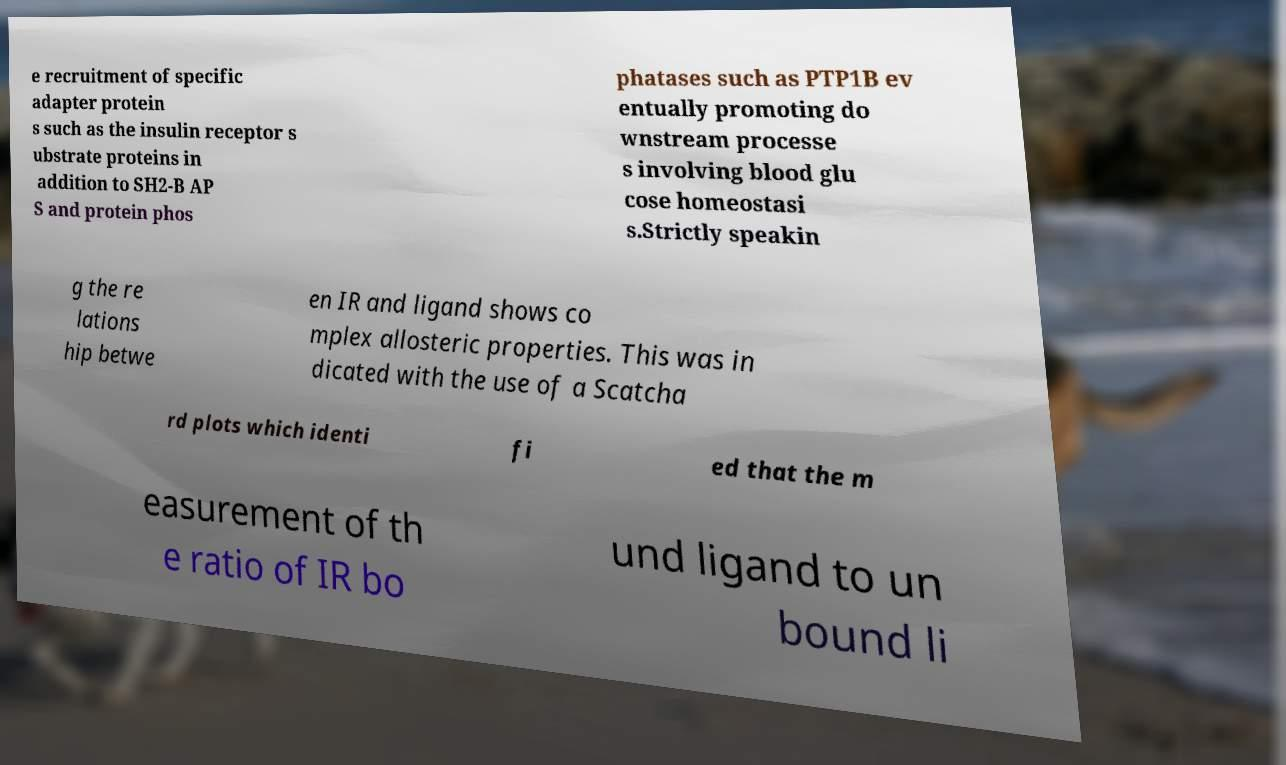There's text embedded in this image that I need extracted. Can you transcribe it verbatim? e recruitment of specific adapter protein s such as the insulin receptor s ubstrate proteins in addition to SH2-B AP S and protein phos phatases such as PTP1B ev entually promoting do wnstream processe s involving blood glu cose homeostasi s.Strictly speakin g the re lations hip betwe en IR and ligand shows co mplex allosteric properties. This was in dicated with the use of a Scatcha rd plots which identi fi ed that the m easurement of th e ratio of IR bo und ligand to un bound li 